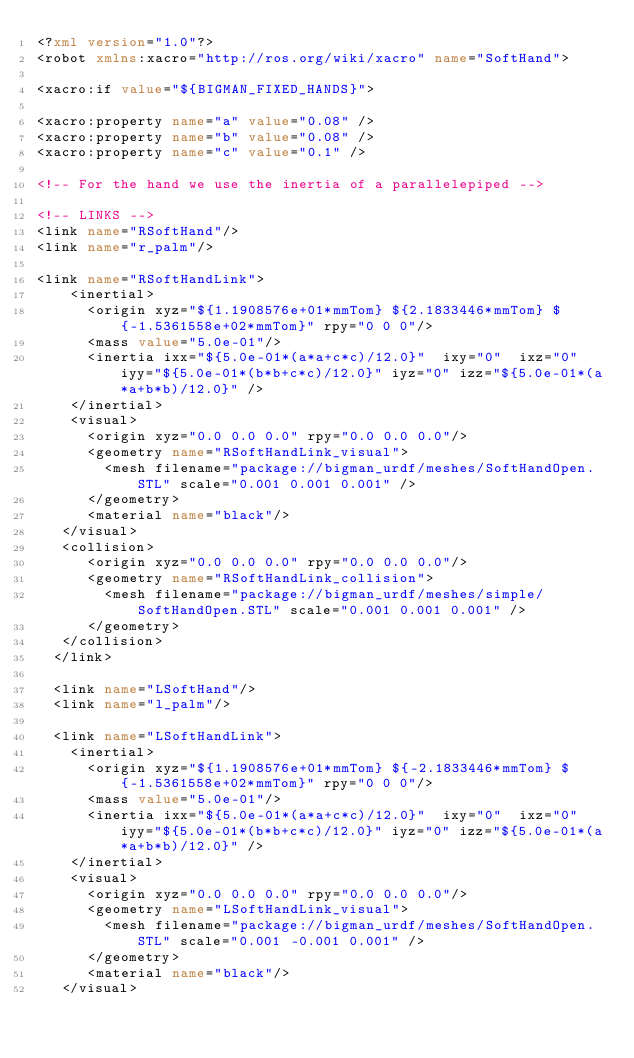Convert code to text. <code><loc_0><loc_0><loc_500><loc_500><_XML_><?xml version="1.0"?>
<robot xmlns:xacro="http://ros.org/wiki/xacro" name="SoftHand">

<xacro:if value="${BIGMAN_FIXED_HANDS}">

<xacro:property name="a" value="0.08" />
<xacro:property name="b" value="0.08" />
<xacro:property name="c" value="0.1" />

<!-- For the hand we use the inertia of a parallelepiped -->

<!-- LINKS -->
<link name="RSoftHand"/>
<link name="r_palm"/>

<link name="RSoftHandLink">
    <inertial>
      <origin xyz="${1.1908576e+01*mmTom} ${2.1833446*mmTom} ${-1.5361558e+02*mmTom}" rpy="0 0 0"/>
      <mass value="5.0e-01"/>
      <inertia ixx="${5.0e-01*(a*a+c*c)/12.0}"  ixy="0"  ixz="0" iyy="${5.0e-01*(b*b+c*c)/12.0}" iyz="0" izz="${5.0e-01*(a*a+b*b)/12.0}" />
    </inertial>
    <visual>
      <origin xyz="0.0 0.0 0.0" rpy="0.0 0.0 0.0"/>
      <geometry name="RSoftHandLink_visual">
        <mesh filename="package://bigman_urdf/meshes/SoftHandOpen.STL" scale="0.001 0.001 0.001" />
      </geometry>
      <material name="black"/>
   </visual>
   <collision>
      <origin xyz="0.0 0.0 0.0" rpy="0.0 0.0 0.0"/>
      <geometry name="RSoftHandLink_collision">
        <mesh filename="package://bigman_urdf/meshes/simple/SoftHandOpen.STL" scale="0.001 0.001 0.001" />
      </geometry>
   </collision>
  </link>

  <link name="LSoftHand"/>
  <link name="l_palm"/>

  <link name="LSoftHandLink">
    <inertial>
      <origin xyz="${1.1908576e+01*mmTom} ${-2.1833446*mmTom} ${-1.5361558e+02*mmTom}" rpy="0 0 0"/>
      <mass value="5.0e-01"/>
      <inertia ixx="${5.0e-01*(a*a+c*c)/12.0}"  ixy="0"  ixz="0" iyy="${5.0e-01*(b*b+c*c)/12.0}" iyz="0" izz="${5.0e-01*(a*a+b*b)/12.0}" />
    </inertial>
    <visual>
      <origin xyz="0.0 0.0 0.0" rpy="0.0 0.0 0.0"/>
      <geometry name="LSoftHandLink_visual">
        <mesh filename="package://bigman_urdf/meshes/SoftHandOpen.STL" scale="0.001 -0.001 0.001" />
      </geometry>
      <material name="black"/>
   </visual></code> 